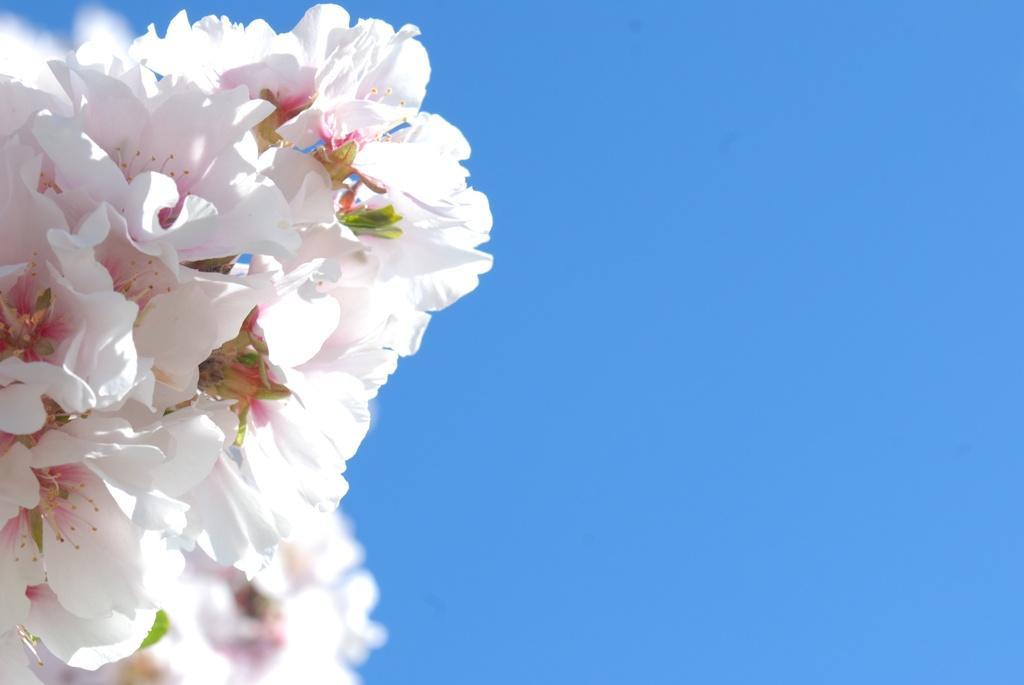Please provide a concise description of this image. In this picture I can see bunch of white flowers, and there is blue background. 